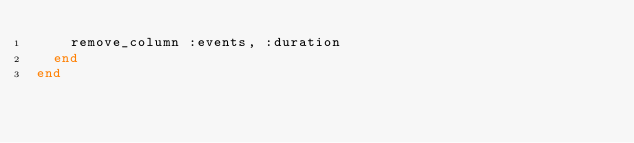<code> <loc_0><loc_0><loc_500><loc_500><_Ruby_>    remove_column :events, :duration
  end
end
</code> 